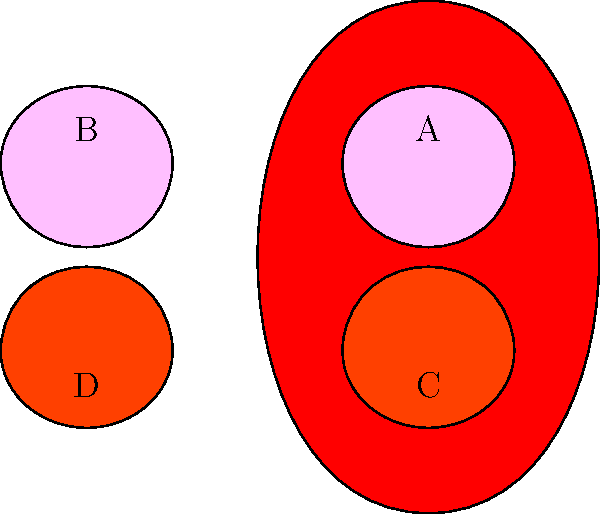In the cross-sectional diagram of the human heart above, identify the labeled parts A, B, C, and D. Which of these chambers is responsible for pumping oxygenated blood to the rest of the body? To answer this question, let's break down the anatomy of the heart:

1. The heart has four main chambers:
   - Two upper chambers called atria
   - Two lower chambers called ventricles

2. Identifying the labeled parts:
   A: Left Atrium
   B: Right Atrium
   C: Left Ventricle
   D: Right Ventricle

3. Functions of each chamber:
   - Right Atrium: Receives deoxygenated blood from the body
   - Right Ventricle: Pumps deoxygenated blood to the lungs
   - Left Atrium: Receives oxygenated blood from the lungs
   - Left Ventricle: Pumps oxygenated blood to the rest of the body

4. The chamber responsible for pumping oxygenated blood to the rest of the body is the Left Ventricle (C).

The Left Ventricle has thicker walls compared to other chambers because it needs to generate higher pressure to pump blood throughout the entire body, whereas the right ventricle only needs to pump blood to the nearby lungs.
Answer: Left Ventricle (C) 